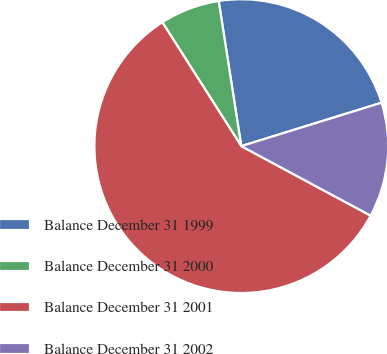Convert chart to OTSL. <chart><loc_0><loc_0><loc_500><loc_500><pie_chart><fcel>Balance December 31 1999<fcel>Balance December 31 2000<fcel>Balance December 31 2001<fcel>Balance December 31 2002<nl><fcel>22.68%<fcel>6.57%<fcel>58.12%<fcel>12.62%<nl></chart> 